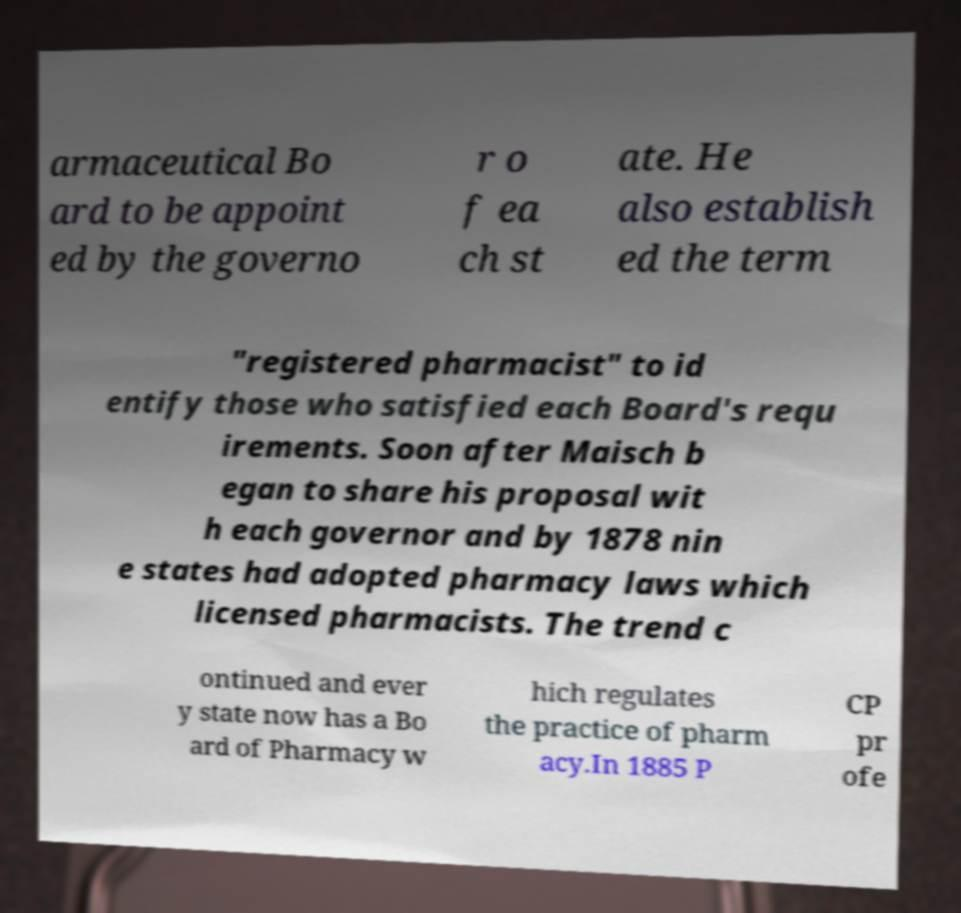Could you assist in decoding the text presented in this image and type it out clearly? armaceutical Bo ard to be appoint ed by the governo r o f ea ch st ate. He also establish ed the term "registered pharmacist" to id entify those who satisfied each Board's requ irements. Soon after Maisch b egan to share his proposal wit h each governor and by 1878 nin e states had adopted pharmacy laws which licensed pharmacists. The trend c ontinued and ever y state now has a Bo ard of Pharmacy w hich regulates the practice of pharm acy.In 1885 P CP pr ofe 